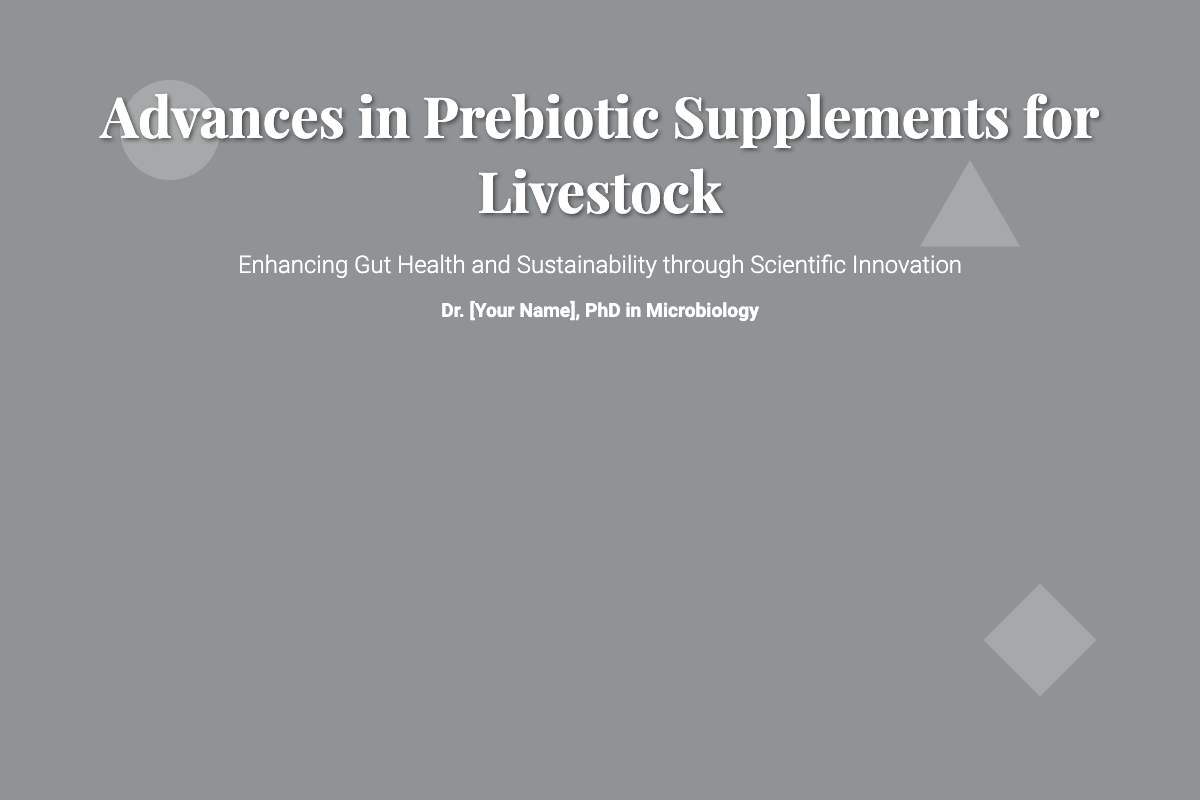What is the title of the book? The title of the book is prominently displayed at the top of the cover.
Answer: Advances in Prebiotic Supplements for Livestock Who is the author of the book? The author’s name is provided below the title in the cover design.
Answer: Dr. [Your Name], PhD in Microbiology What is the subtitle of the book? The subtitle is located below the title and provides insight into the book's theme.
Answer: Enhancing Gut Health and Sustainability through Scientific Innovation What type of structures are illustrated in the background? The background features specific elements related to the subject of the book.
Answer: Prebiotic structures What is the primary focus of the book? The subtitle highlights the main aim or focus of the book.
Answer: Gut Health and Sustainability How many shapes are used as decorative elements in the design? The decorative elements include three distinct shapes placed strategically on the cover.
Answer: Three What color is the overlay on the book cover? The overlay's color plays a role in the visual presentation of the cover design.
Answer: Black (rgba(0, 0, 0, 0.4)) Where is the title placed on the cover? The title is positioned at a specific location for visibility and emphasis.
Answer: Center top What style of text is used for the title? The font style conveys a particular theme or tone for the book cover.
Answer: Playfair Display What is the font size of the subtitle? The font size of the subtitle indicates its importance in the design hierarchy.
Answer: 1.5em 